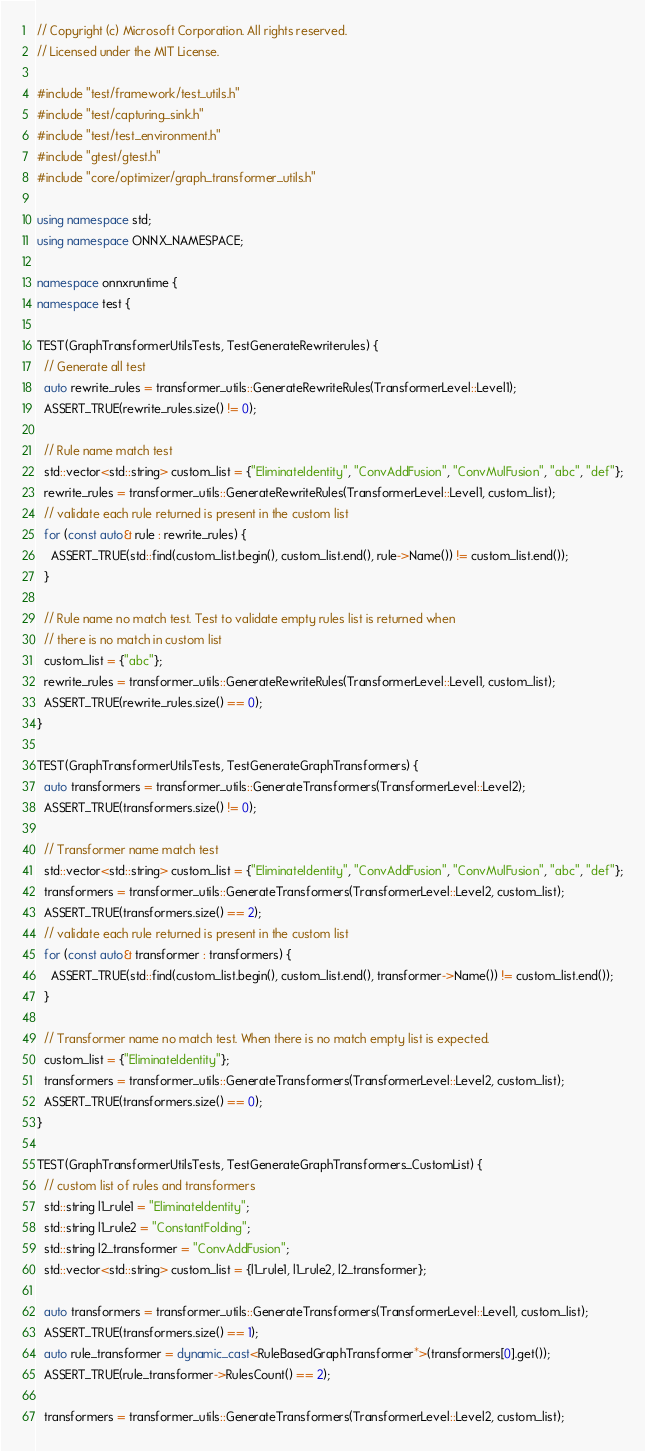Convert code to text. <code><loc_0><loc_0><loc_500><loc_500><_C++_>// Copyright (c) Microsoft Corporation. All rights reserved.
// Licensed under the MIT License.

#include "test/framework/test_utils.h"
#include "test/capturing_sink.h"
#include "test/test_environment.h"
#include "gtest/gtest.h"
#include "core/optimizer/graph_transformer_utils.h"

using namespace std;
using namespace ONNX_NAMESPACE;

namespace onnxruntime {
namespace test {

TEST(GraphTransformerUtilsTests, TestGenerateRewriterules) {
  // Generate all test
  auto rewrite_rules = transformer_utils::GenerateRewriteRules(TransformerLevel::Level1);
  ASSERT_TRUE(rewrite_rules.size() != 0);

  // Rule name match test
  std::vector<std::string> custom_list = {"EliminateIdentity", "ConvAddFusion", "ConvMulFusion", "abc", "def"};
  rewrite_rules = transformer_utils::GenerateRewriteRules(TransformerLevel::Level1, custom_list);
  // validate each rule returned is present in the custom list
  for (const auto& rule : rewrite_rules) {
    ASSERT_TRUE(std::find(custom_list.begin(), custom_list.end(), rule->Name()) != custom_list.end());
  }

  // Rule name no match test. Test to validate empty rules list is returned when
  // there is no match in custom list
  custom_list = {"abc"};
  rewrite_rules = transformer_utils::GenerateRewriteRules(TransformerLevel::Level1, custom_list);
  ASSERT_TRUE(rewrite_rules.size() == 0);
}

TEST(GraphTransformerUtilsTests, TestGenerateGraphTransformers) {
  auto transformers = transformer_utils::GenerateTransformers(TransformerLevel::Level2);
  ASSERT_TRUE(transformers.size() != 0);

  // Transformer name match test
  std::vector<std::string> custom_list = {"EliminateIdentity", "ConvAddFusion", "ConvMulFusion", "abc", "def"};
  transformers = transformer_utils::GenerateTransformers(TransformerLevel::Level2, custom_list);
  ASSERT_TRUE(transformers.size() == 2);
  // validate each rule returned is present in the custom list
  for (const auto& transformer : transformers) {
    ASSERT_TRUE(std::find(custom_list.begin(), custom_list.end(), transformer->Name()) != custom_list.end());
  }

  // Transformer name no match test. When there is no match empty list is expected.
  custom_list = {"EliminateIdentity"};
  transformers = transformer_utils::GenerateTransformers(TransformerLevel::Level2, custom_list);
  ASSERT_TRUE(transformers.size() == 0);
}

TEST(GraphTransformerUtilsTests, TestGenerateGraphTransformers_CustomList) {
  // custom list of rules and transformers
  std::string l1_rule1 = "EliminateIdentity";
  std::string l1_rule2 = "ConstantFolding";
  std::string l2_transformer = "ConvAddFusion";
  std::vector<std::string> custom_list = {l1_rule1, l1_rule2, l2_transformer};

  auto transformers = transformer_utils::GenerateTransformers(TransformerLevel::Level1, custom_list);
  ASSERT_TRUE(transformers.size() == 1);
  auto rule_transformer = dynamic_cast<RuleBasedGraphTransformer*>(transformers[0].get());
  ASSERT_TRUE(rule_transformer->RulesCount() == 2);
  
  transformers = transformer_utils::GenerateTransformers(TransformerLevel::Level2, custom_list);</code> 